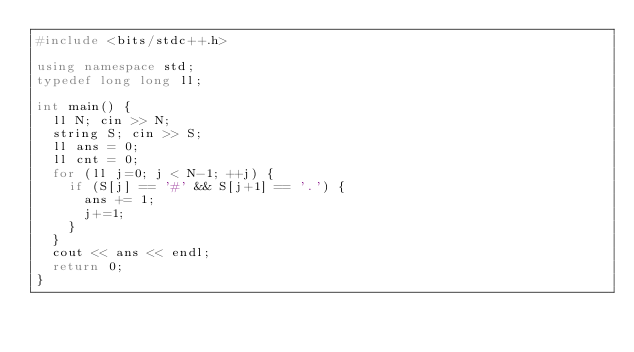<code> <loc_0><loc_0><loc_500><loc_500><_C++_>#include <bits/stdc++.h>

using namespace std;
typedef long long ll;

int main() {
  ll N; cin >> N;
  string S; cin >> S;
  ll ans = 0;
  ll cnt = 0;
  for (ll j=0; j < N-1; ++j) {
    if (S[j] == '#' && S[j+1] == '.') {
      ans += 1;
      j+=1;
    }
  }
  cout << ans << endl;
  return 0;
}
</code> 